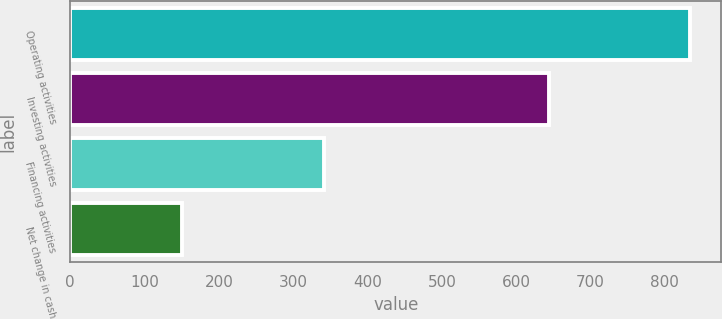Convert chart. <chart><loc_0><loc_0><loc_500><loc_500><bar_chart><fcel>Operating activities<fcel>Investing activities<fcel>Financing activities<fcel>Net change in cash<nl><fcel>834<fcel>644<fcel>341<fcel>151<nl></chart> 